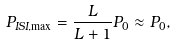<formula> <loc_0><loc_0><loc_500><loc_500>P _ { I S I , \max } = \frac { L } { L + 1 } P _ { 0 } \approx P _ { 0 } ,</formula> 